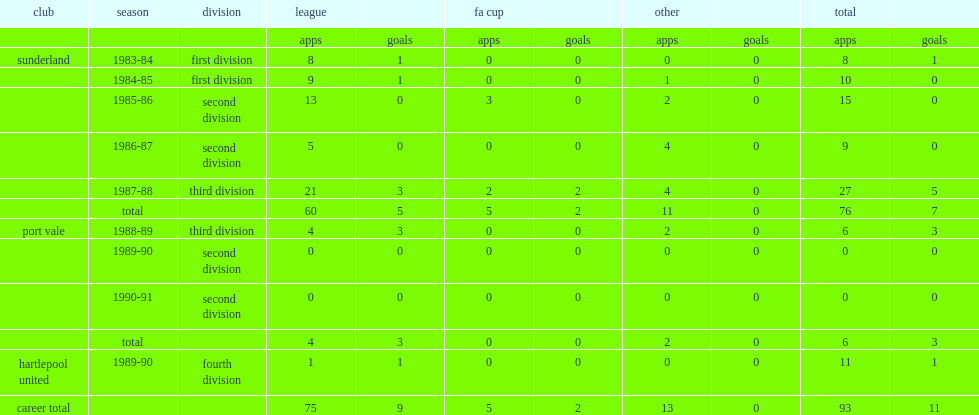Paul atkinson began his career at sunderland, which division did he play in the 1987-88? Third division. 